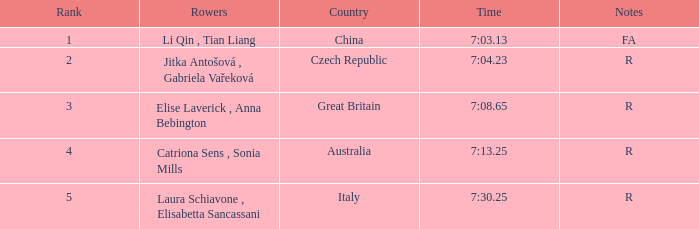What is the Rank of the Rowers with FA as Notes? 1.0. 